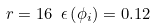Convert formula to latex. <formula><loc_0><loc_0><loc_500><loc_500>r = 1 6 \ \epsilon \left ( \phi _ { i } \right ) = 0 . 1 2</formula> 